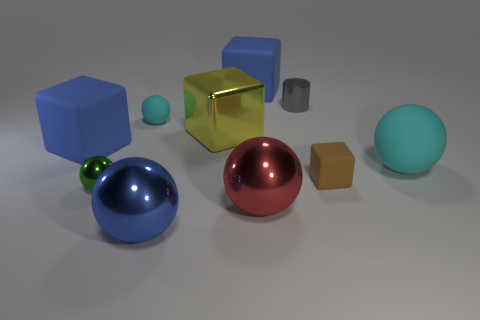Subtract all tiny brown blocks. How many blocks are left? 3 Subtract all red balls. How many balls are left? 4 Subtract all cylinders. How many objects are left? 9 Subtract 1 cylinders. How many cylinders are left? 0 Subtract all gray objects. Subtract all rubber cubes. How many objects are left? 6 Add 2 big red spheres. How many big red spheres are left? 3 Add 9 red shiny spheres. How many red shiny spheres exist? 10 Subtract 0 purple cylinders. How many objects are left? 10 Subtract all cyan cylinders. Subtract all brown blocks. How many cylinders are left? 1 Subtract all brown balls. How many yellow blocks are left? 1 